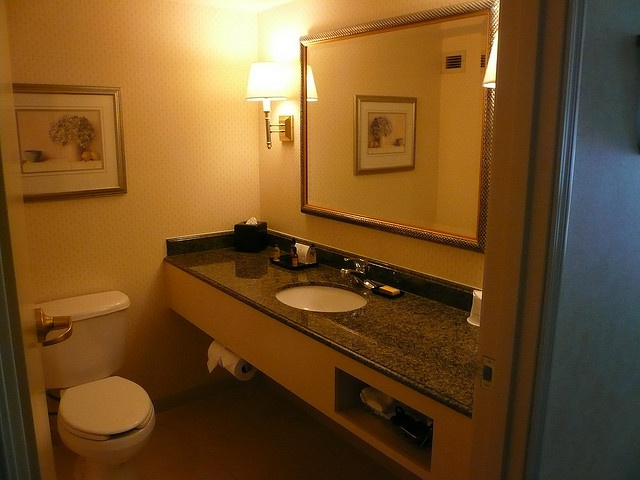Describe the objects in this image and their specific colors. I can see toilet in olive, maroon, and black tones and sink in olive and tan tones in this image. 